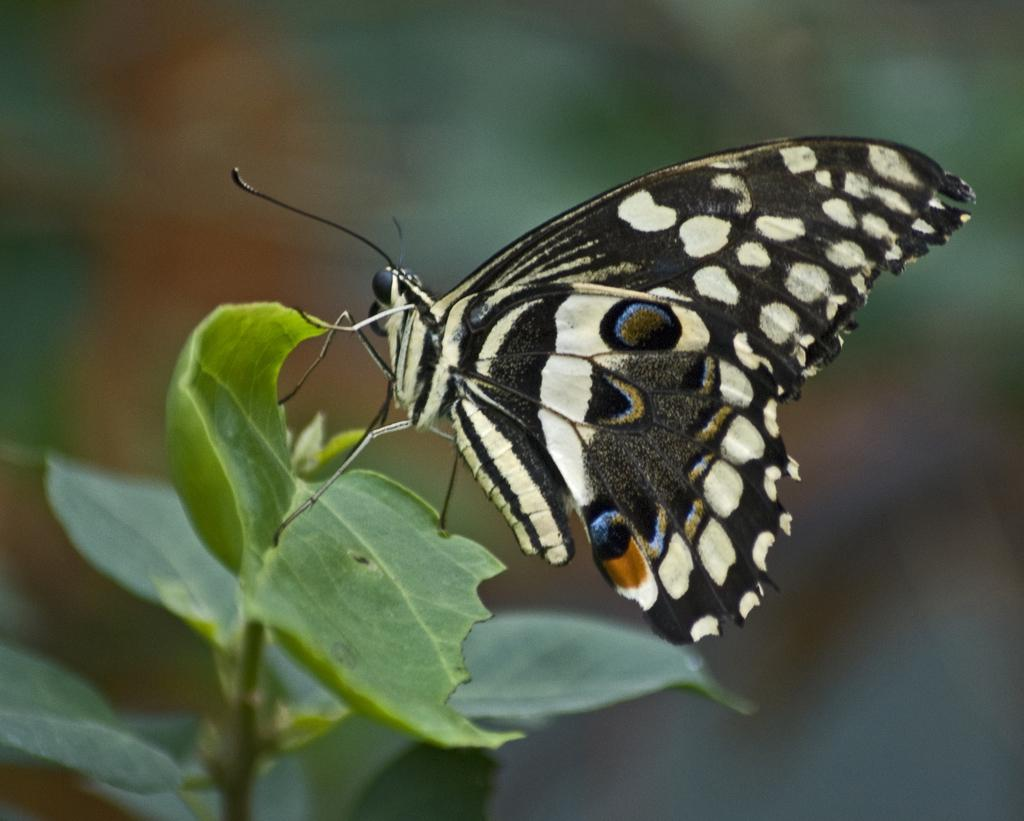What type of insect can be seen in the picture? There is a butterfly in the picture. What type of vegetation is present in the picture? There are green leaves in the picture. What is the end result of the reading process in the picture? There is no reading process or end result depicted in the picture, as it features a butterfly and green leaves. 